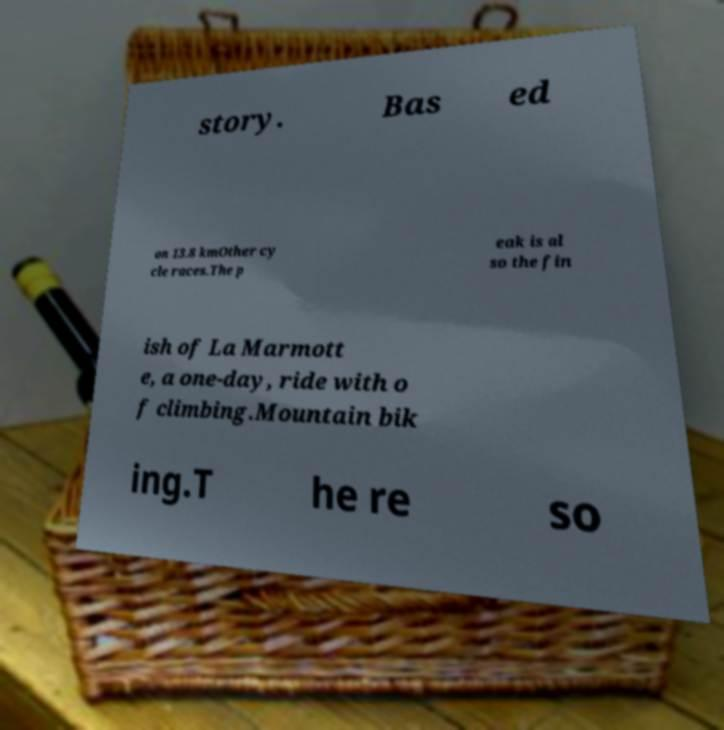Please read and relay the text visible in this image. What does it say? story. Bas ed on 13.8 kmOther cy cle races.The p eak is al so the fin ish of La Marmott e, a one-day, ride with o f climbing.Mountain bik ing.T he re so 